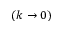<formula> <loc_0><loc_0><loc_500><loc_500>( k \to 0 )</formula> 